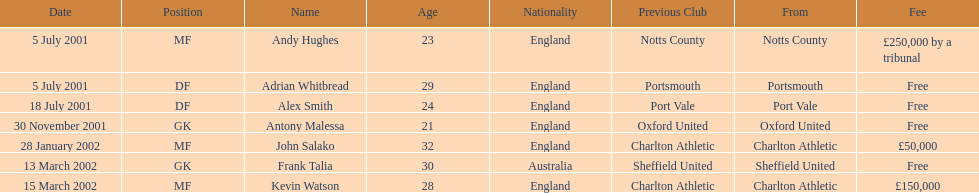Which transfer in was next after john salako's in 2002? Frank Talia. 